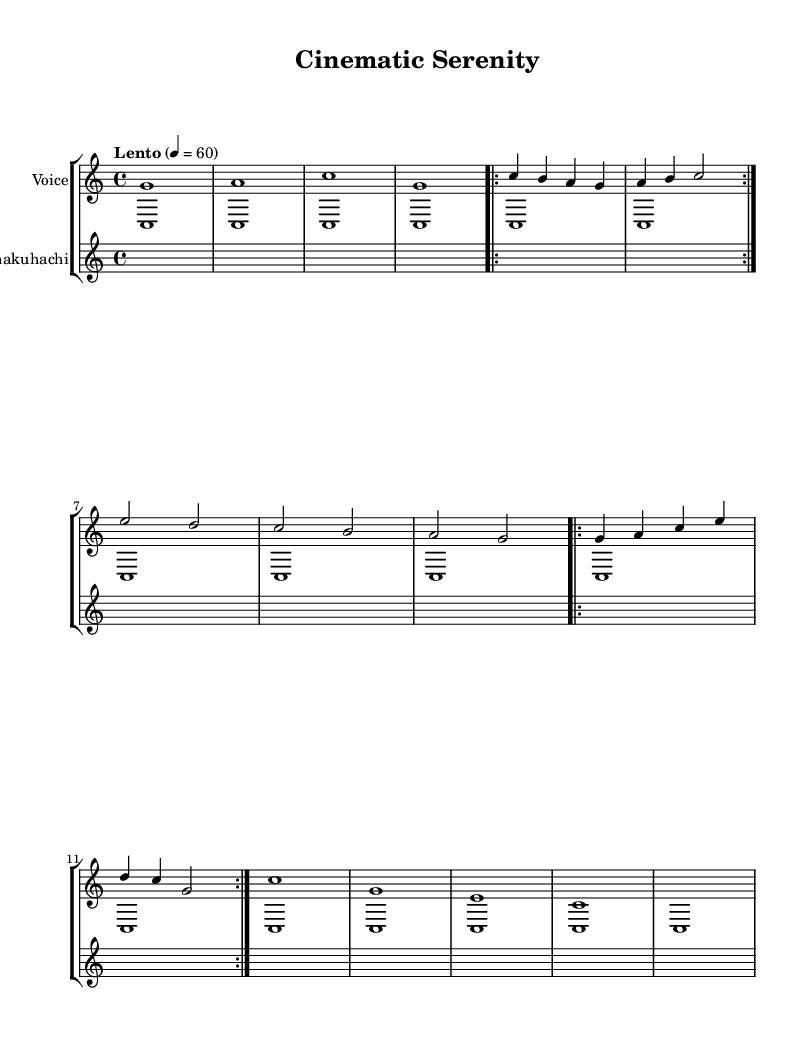What is the key signature of this music? The key signature is C major, which has no sharps or flats.
Answer: C major What is the time signature of this piece? The time signature is found at the beginning, indicated by the fraction which shows 4 beats per measure.
Answer: 4/4 What is the tempo marking for this piece? The tempo marking is indicated above the staff, with the word "Lento" and a metronome marking of 60 beats per minute.
Answer: Lento How many repetitions of Chant A are indicated in the score? The score indicates that Chant A is repeated 2 times, as seen in the repeat markings labeled "volta 2".
Answer: 2 How many measures are there in the entire piece? The score consists of several segments including the introduction, two chants, and the outro, totaling 14 measures when counted.
Answer: 14 What instruments are indicated in the score? The score shows a “Voice” staff for the vocal part and a “Shakuhachi” staff for the traditional flute, along with the singing bowl accompaniment.
Answer: Voice and Shakuhachi Which elements suggest that this is a meditative piece? The use of a slow tempo (Lento), the repetitive chant structure, and the inclusion of a singing bowl suggest a calming, meditative quality.
Answer: Slow tempo and repetition 